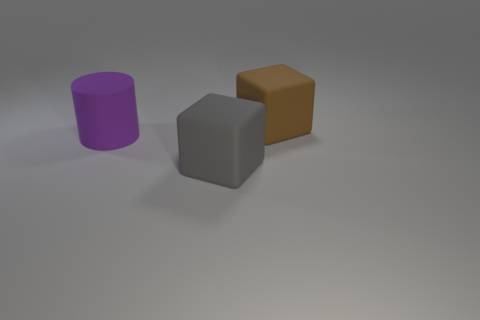Add 1 small gray balls. How many objects exist? 4 Subtract all brown blocks. How many blocks are left? 1 Subtract 1 cylinders. How many cylinders are left? 0 Subtract all blocks. How many objects are left? 1 Subtract 0 cyan cylinders. How many objects are left? 3 Subtract all yellow cylinders. Subtract all brown balls. How many cylinders are left? 1 Subtract all purple things. Subtract all big purple cylinders. How many objects are left? 1 Add 2 gray rubber objects. How many gray rubber objects are left? 3 Add 1 gray spheres. How many gray spheres exist? 1 